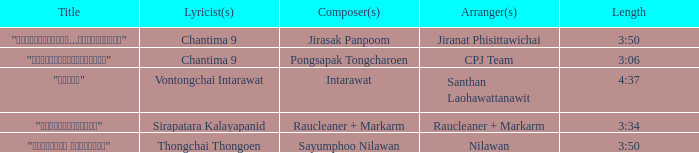Who was the arranger for the song that had a lyricist of Sirapatara Kalayapanid? Raucleaner + Markarm. 